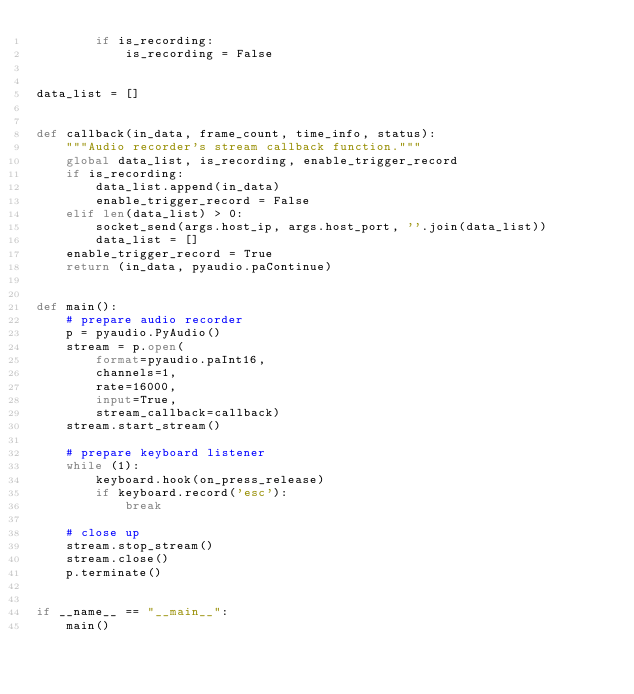<code> <loc_0><loc_0><loc_500><loc_500><_Python_>        if is_recording:
            is_recording = False


data_list = []


def callback(in_data, frame_count, time_info, status):
    """Audio recorder's stream callback function."""
    global data_list, is_recording, enable_trigger_record
    if is_recording:
        data_list.append(in_data)
        enable_trigger_record = False
    elif len(data_list) > 0:
        socket_send(args.host_ip, args.host_port, ''.join(data_list))
        data_list = []
    enable_trigger_record = True
    return (in_data, pyaudio.paContinue)


def main():
    # prepare audio recorder
    p = pyaudio.PyAudio()
    stream = p.open(
        format=pyaudio.paInt16,
        channels=1,
        rate=16000,
        input=True,
        stream_callback=callback)
    stream.start_stream()

    # prepare keyboard listener
    while (1):
        keyboard.hook(on_press_release)
        if keyboard.record('esc'):
            break

    # close up
    stream.stop_stream()
    stream.close()
    p.terminate()


if __name__ == "__main__":
    main()
</code> 